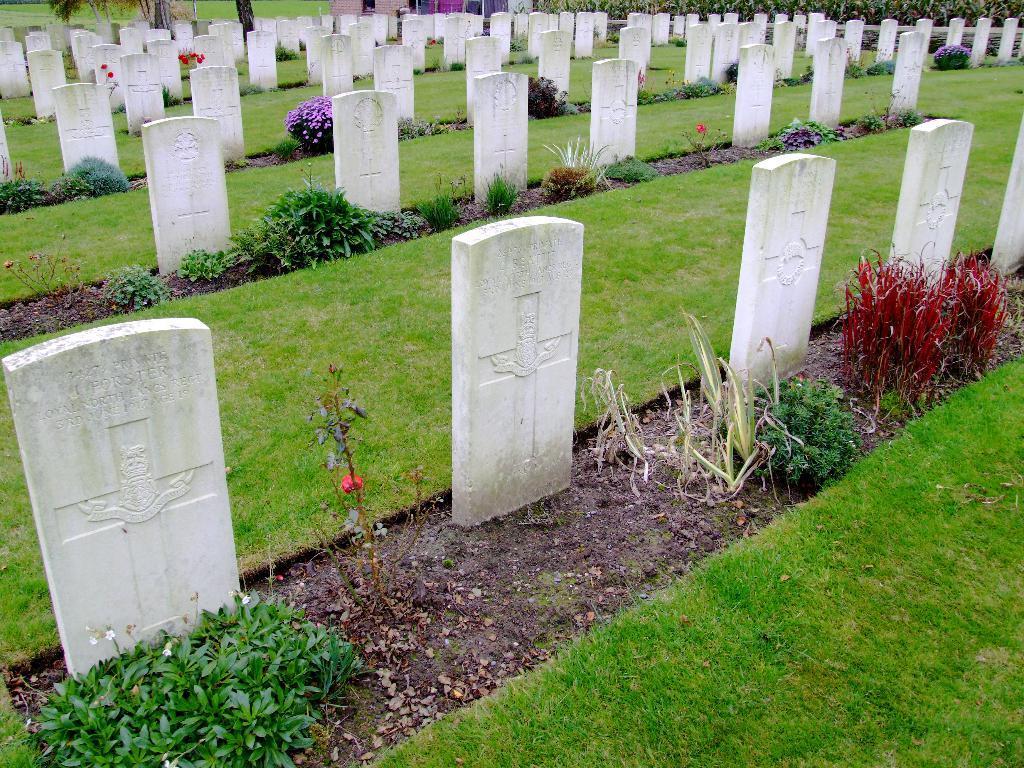How would you summarize this image in a sentence or two? We can see graveyard and there are plants with flowers and grass on the ground. At the top there are plants and other objects. 